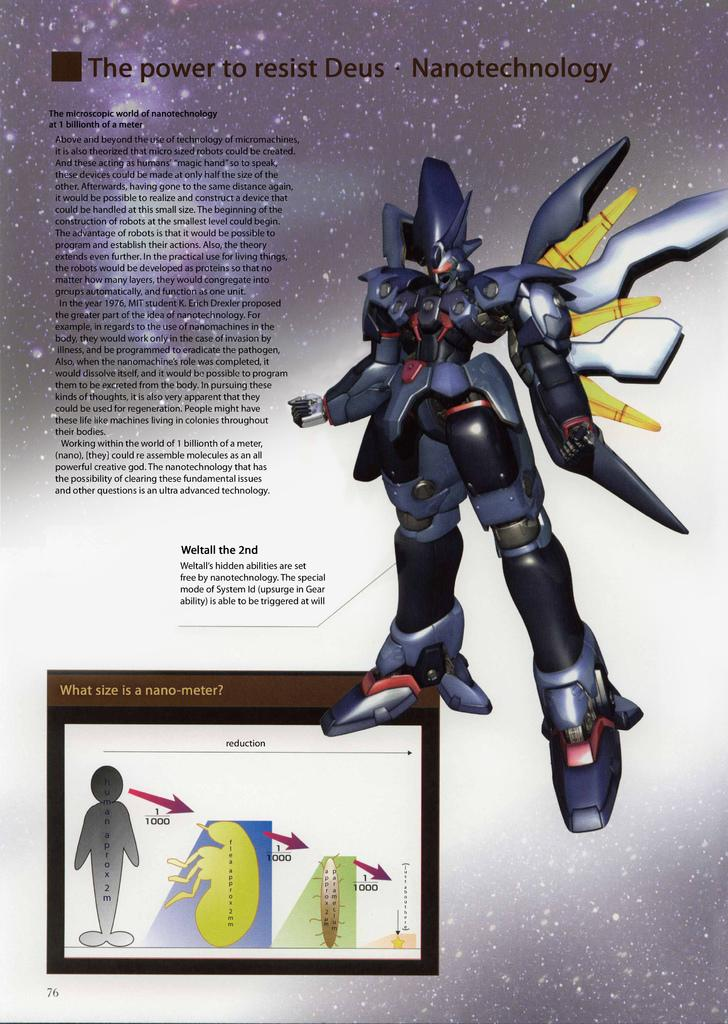<image>
Provide a brief description of the given image. a paper that has nanotechnology on it with a robot 